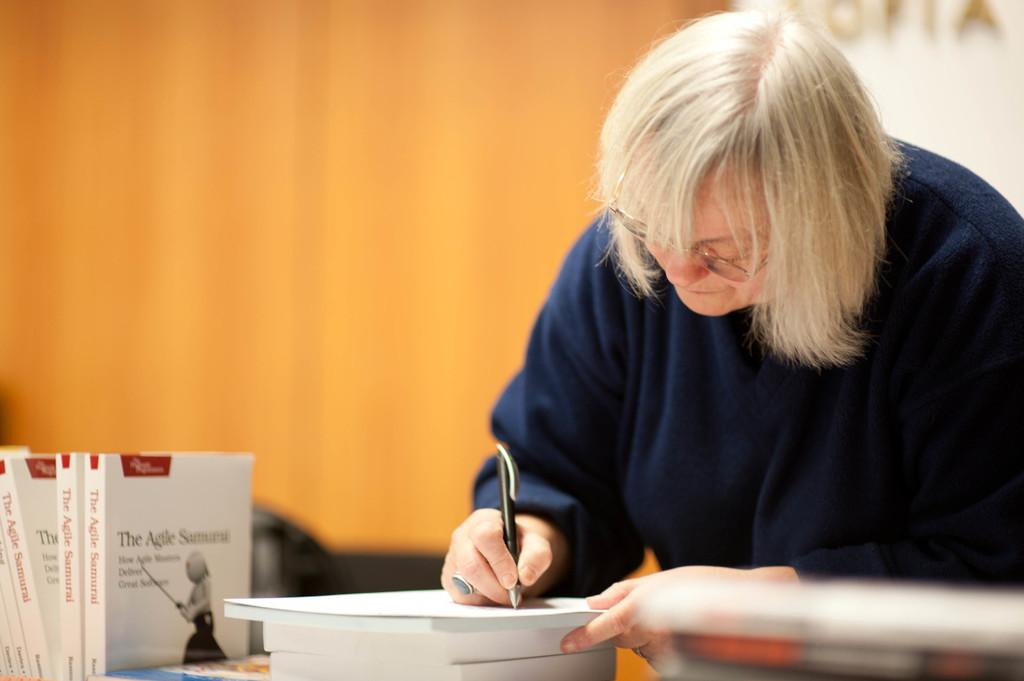Provide a one-sentence caption for the provided image. A blonde woman is using a pen and standing near several copies of a book called "The Agile Samurai". 